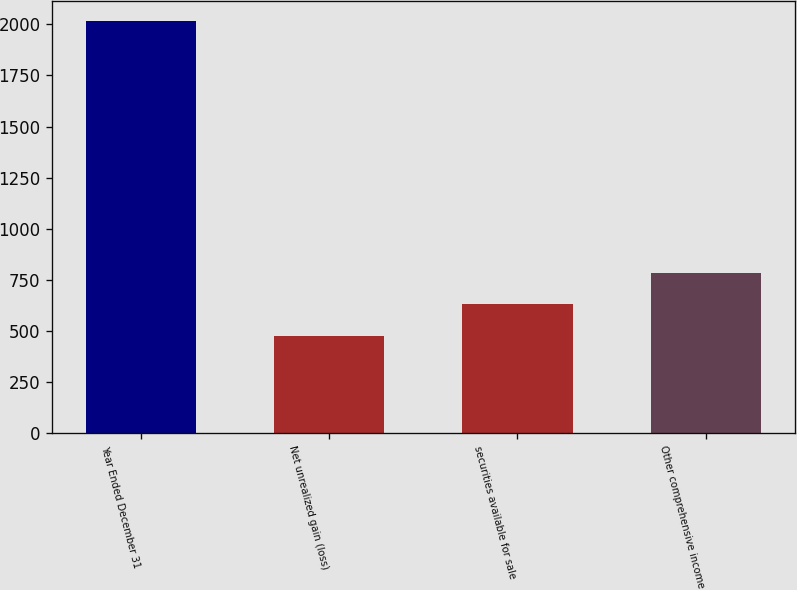Convert chart to OTSL. <chart><loc_0><loc_0><loc_500><loc_500><bar_chart><fcel>Year Ended December 31<fcel>Net unrealized gain (loss)<fcel>securities available for sale<fcel>Other comprehensive income<nl><fcel>2015<fcel>477<fcel>630.8<fcel>784.6<nl></chart> 